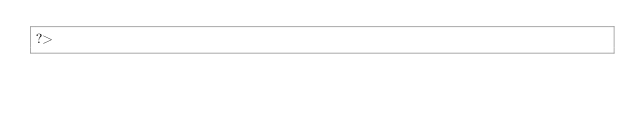<code> <loc_0><loc_0><loc_500><loc_500><_PHP_>?>

</code> 